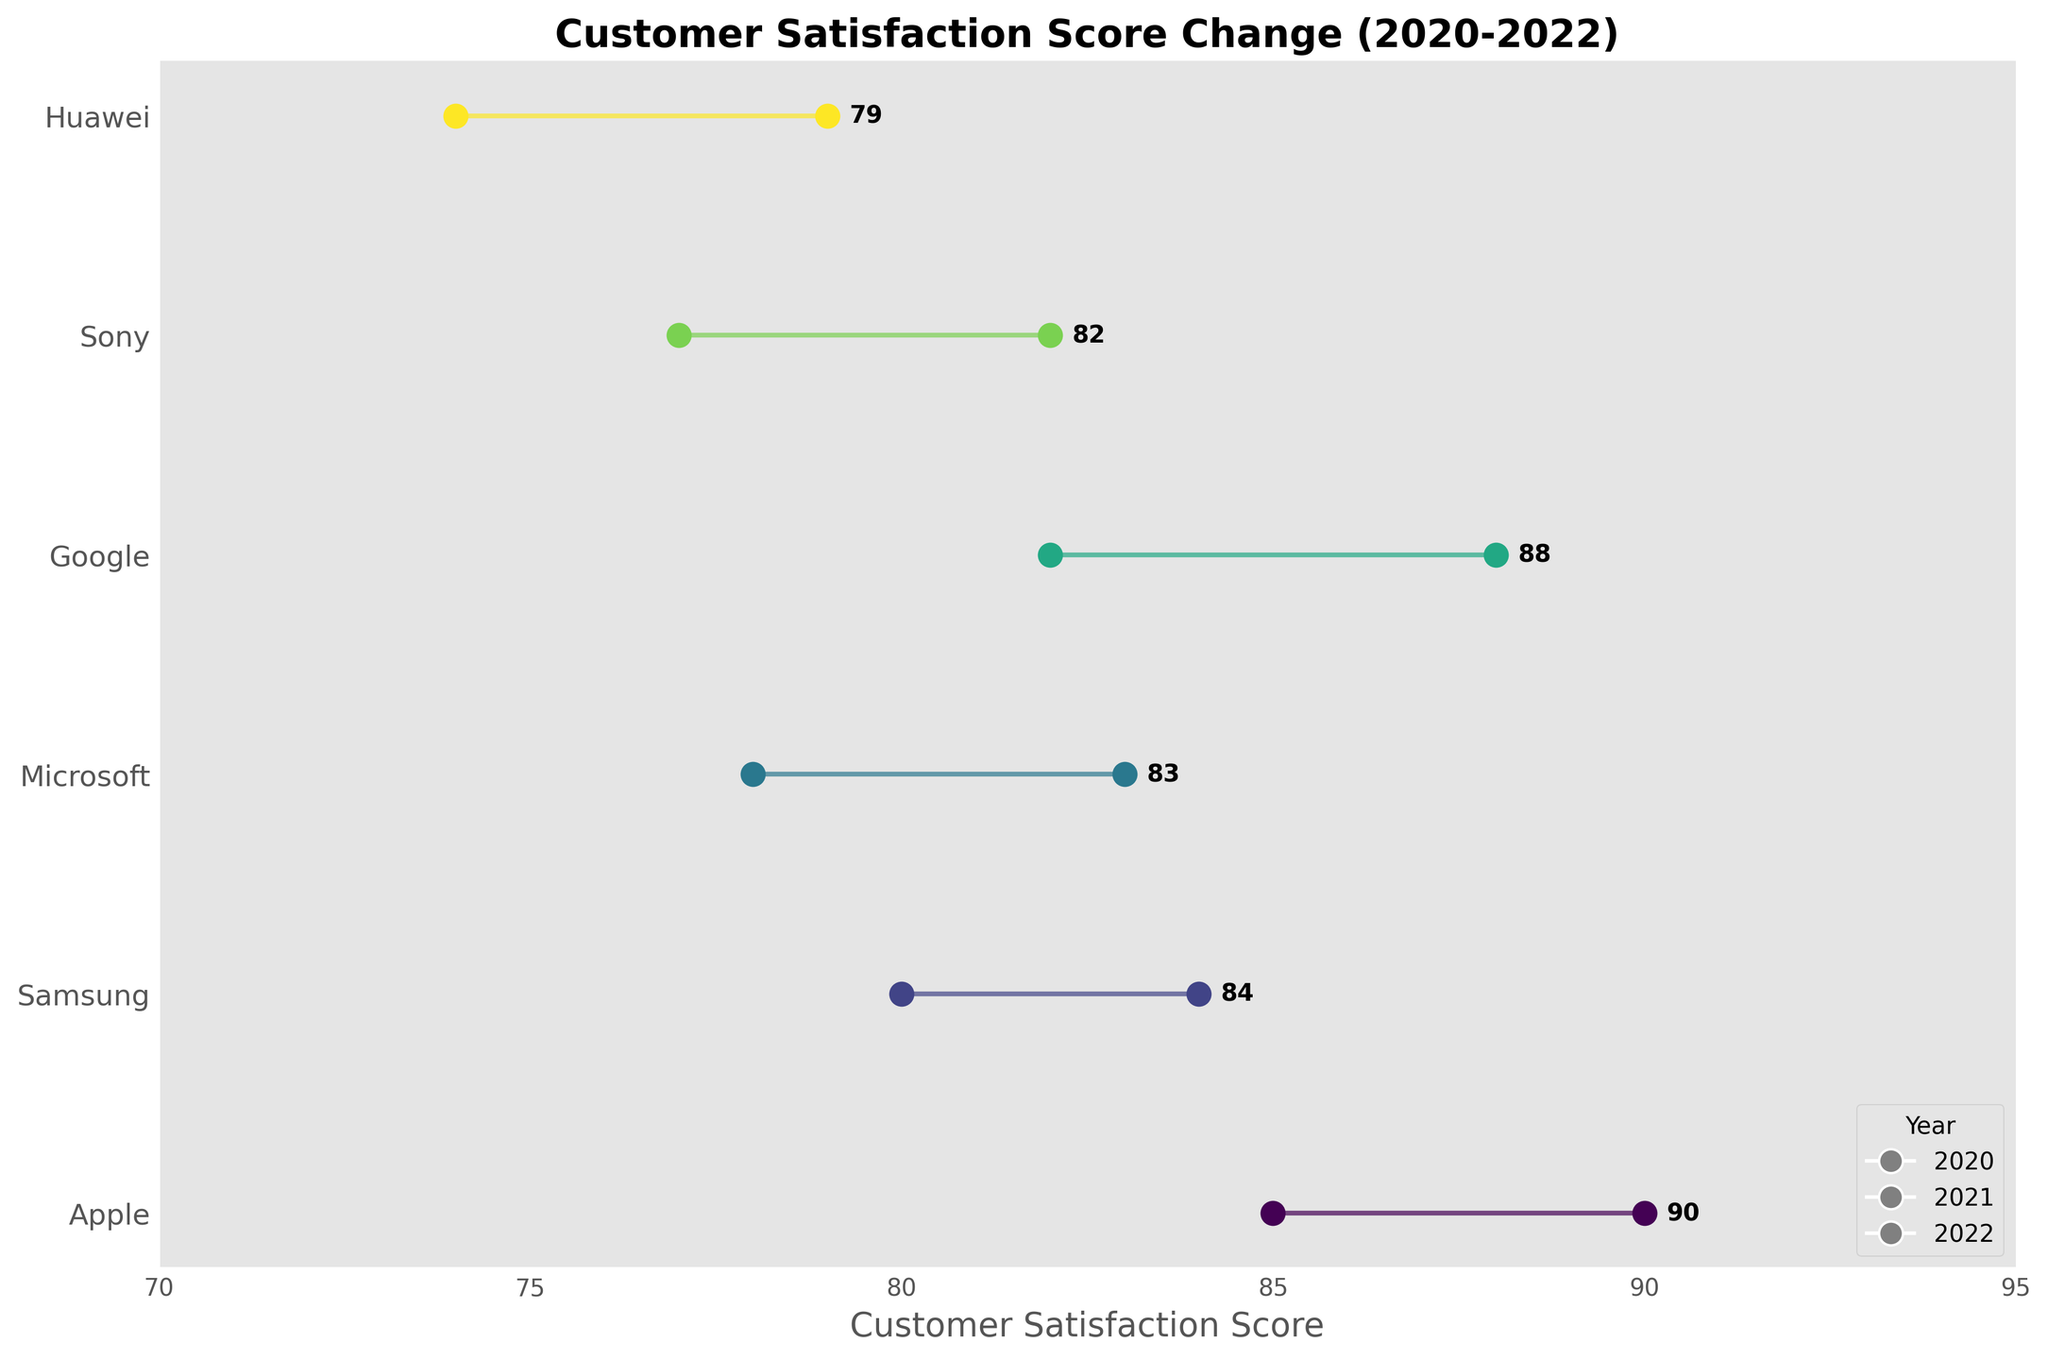What is the title of the plot? The title of the plot is located at the top of the figure and is always descriptive of the content being displayed.
Answer: Customer Satisfaction Score Change (2020-2022) Which year has the highest customer satisfaction score for Apple? Look at the endpoints of the line for Apple (the dumbbell plot) and observe the text annotations. The highest score will be at the end of the line for the final year.
Answer: 2022 How many companies are shown in the plot? Count the unique company names listed along the vertical axis (y-axis) of the plot.
Answer: 6 Which company had the largest increase in customer satisfaction scores between 2020 and 2022? Identify the companies with the largest horizontal difference (distance) between the start and end points of their lines. Compare these differences to find the largest.
Answer: Apple What was the customer satisfaction score change for Sony from 2020 to 2022? Subtract the starting customer satisfaction score for Sony in 2020 from the ending score in 2022.
Answer: 5 (82 - 77) Which year is represented by the markers on the left side of the lines? The marker on the left side of each line represents the starting year, which in this plot is the earliest year available.
Answer: 2020 Is there any company whose customer satisfaction score didn't increase from 2020 to 2022? Observe the lines and markers to see if any company's end point doesn't exceed its start point.
Answer: No What is the average customer satisfaction score in 2022 across all companies? Add the customer satisfaction scores for all companies in 2022 and divide by the number of companies. The scores are 90, 84, 83, 88, 82, 79. Sum these and divide by 6.
Answer: 84.3 Which company had the lowest customer satisfaction score in 2020? Compare the starting points of all companies and identify the smallest value.
Answer: Huawei 